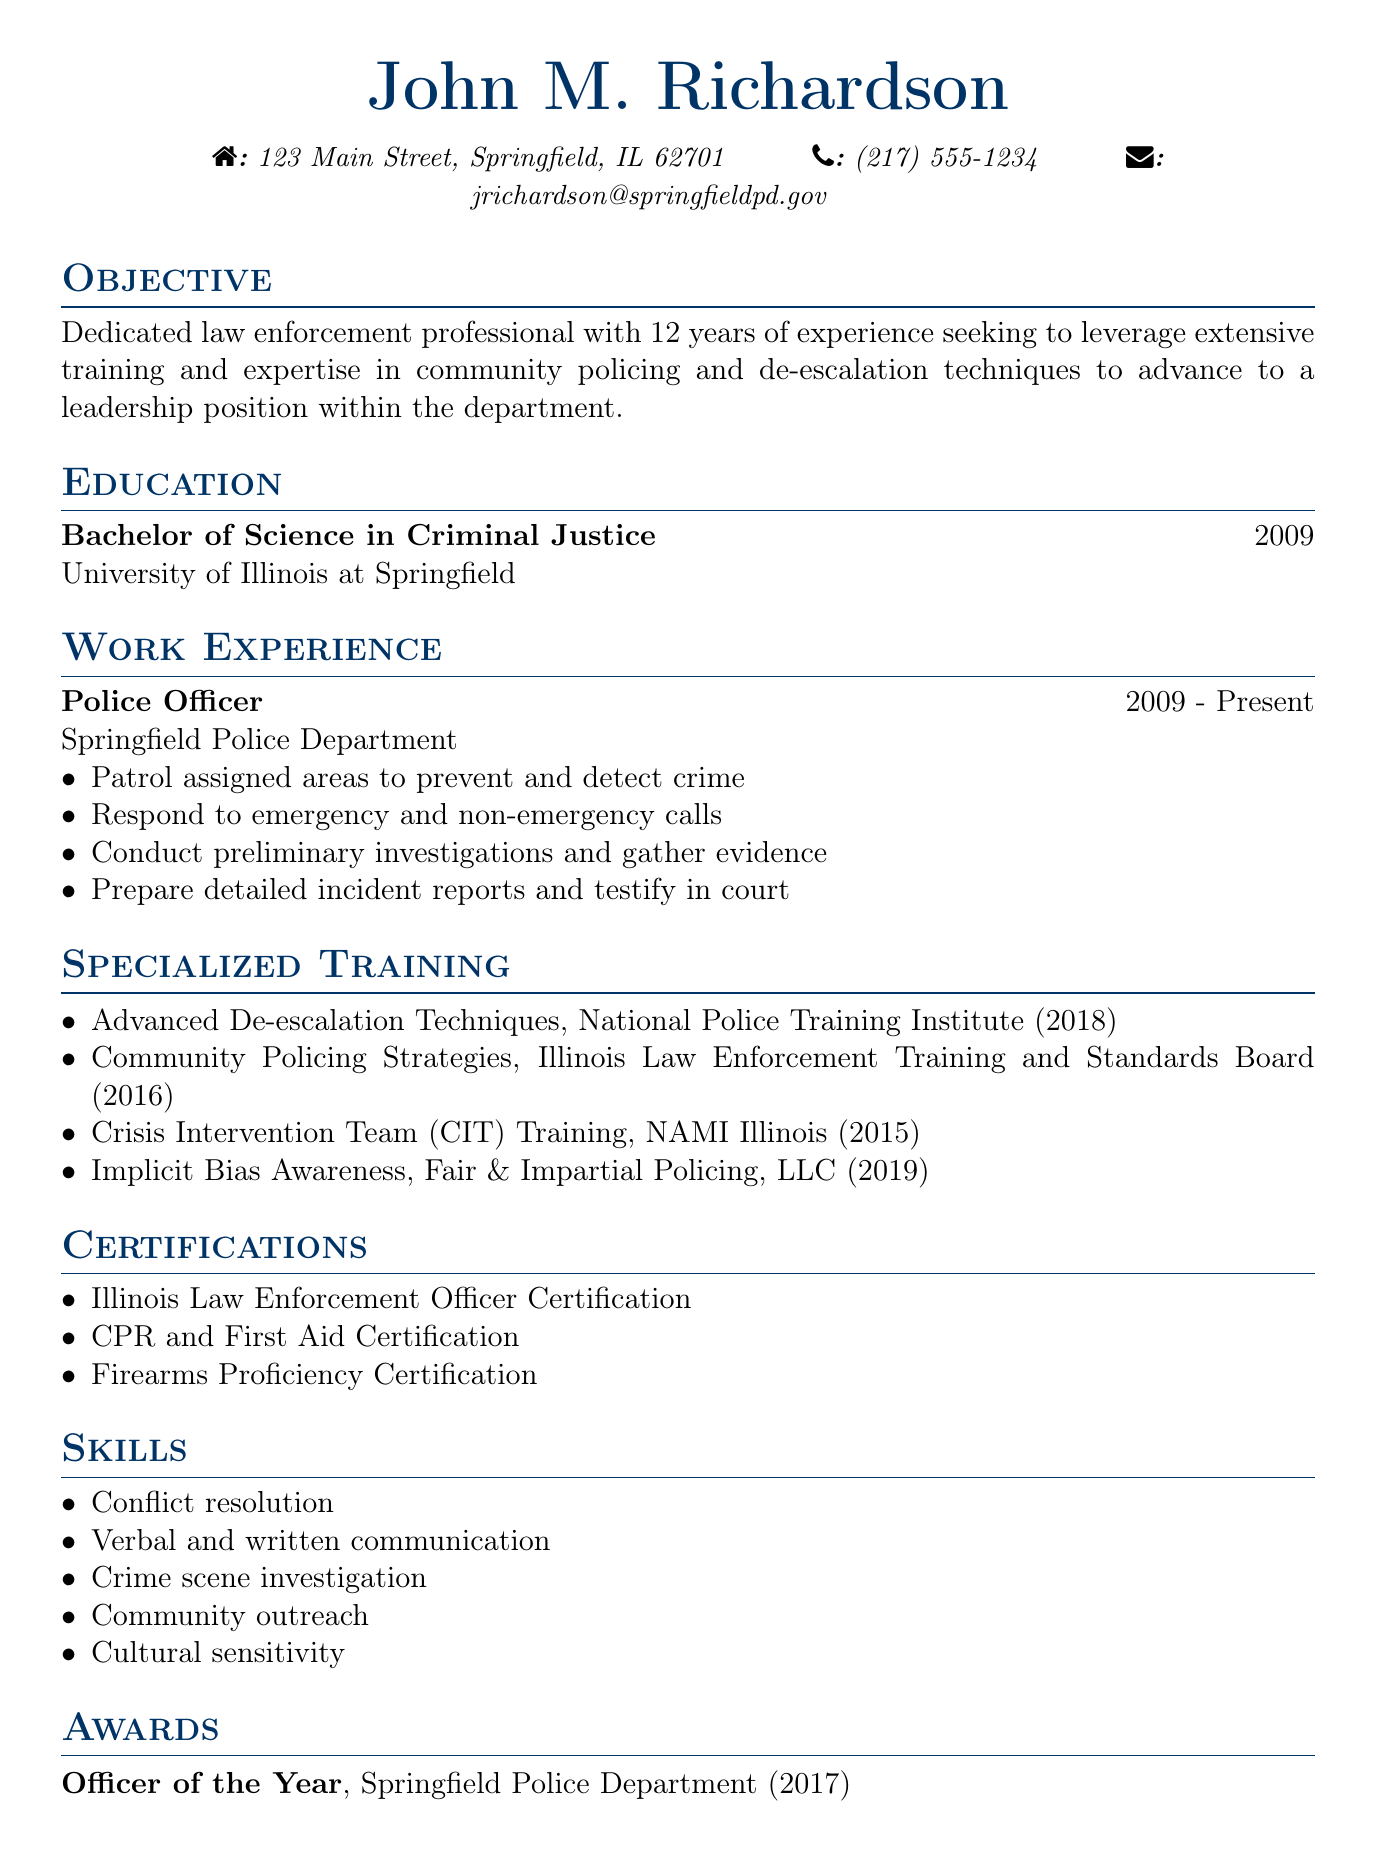What is the name of the individual? The document presents the name of the individual at the beginning, which is John M. Richardson.
Answer: John M. Richardson What is the degree obtained? This information is found in the education section, indicating that the individual obtained a Bachelor of Science in Criminal Justice.
Answer: Bachelor of Science in Criminal Justice In which year did John M. Richardson complete his degree? The year is mentioned alongside the degree in the education section, which states 2009.
Answer: 2009 What position does John M. Richardson currently hold? This is specified under work experience, where he is described as a Police Officer.
Answer: Police Officer How many years of experience does John M. Richardson have? The objective section states he has 12 years of experience in law enforcement.
Answer: 12 years Which training course was completed in 2018? The specialized training section lists the course Advanced De-escalation Techniques, which was completed in 2018.
Answer: Advanced De-escalation Techniques What award did he receive in 2017? The awards section highlights that he was named Officer of the Year by the Springfield Police Department.
Answer: Officer of the Year What skills are listed in the document? The skills section provides multiple skills, including conflict resolution, verbal communication, and cultural sensitivity, among others.
Answer: Conflict resolution, verbal and written communication, crime scene investigation, community outreach, cultural sensitivity Which organization provided the course on Community Policing Strategies? This information comes from the specialized training section, where it indicates that the course was provided by the Illinois Law Enforcement Training and Standards Board.
Answer: Illinois Law Enforcement Training and Standards Board What is the objective stated in the CV? The objective section outlines the individual's aim to leverage extensive training in community policing and de-escalation techniques for a leadership role.
Answer: To advance to a leadership position within the department 